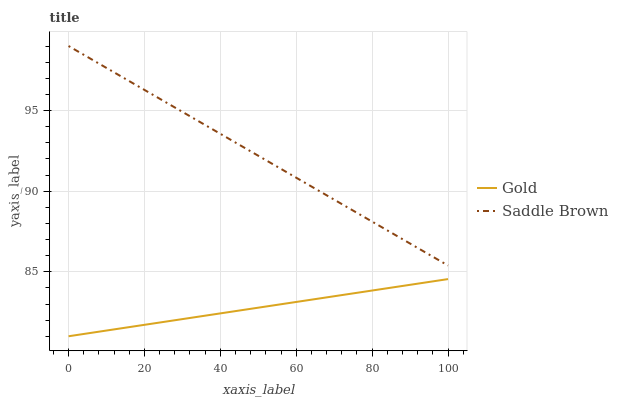Does Gold have the minimum area under the curve?
Answer yes or no. Yes. Does Saddle Brown have the maximum area under the curve?
Answer yes or no. Yes. Does Gold have the maximum area under the curve?
Answer yes or no. No. Is Gold the smoothest?
Answer yes or no. Yes. Is Saddle Brown the roughest?
Answer yes or no. Yes. Is Gold the roughest?
Answer yes or no. No. Does Gold have the highest value?
Answer yes or no. No. Is Gold less than Saddle Brown?
Answer yes or no. Yes. Is Saddle Brown greater than Gold?
Answer yes or no. Yes. Does Gold intersect Saddle Brown?
Answer yes or no. No. 